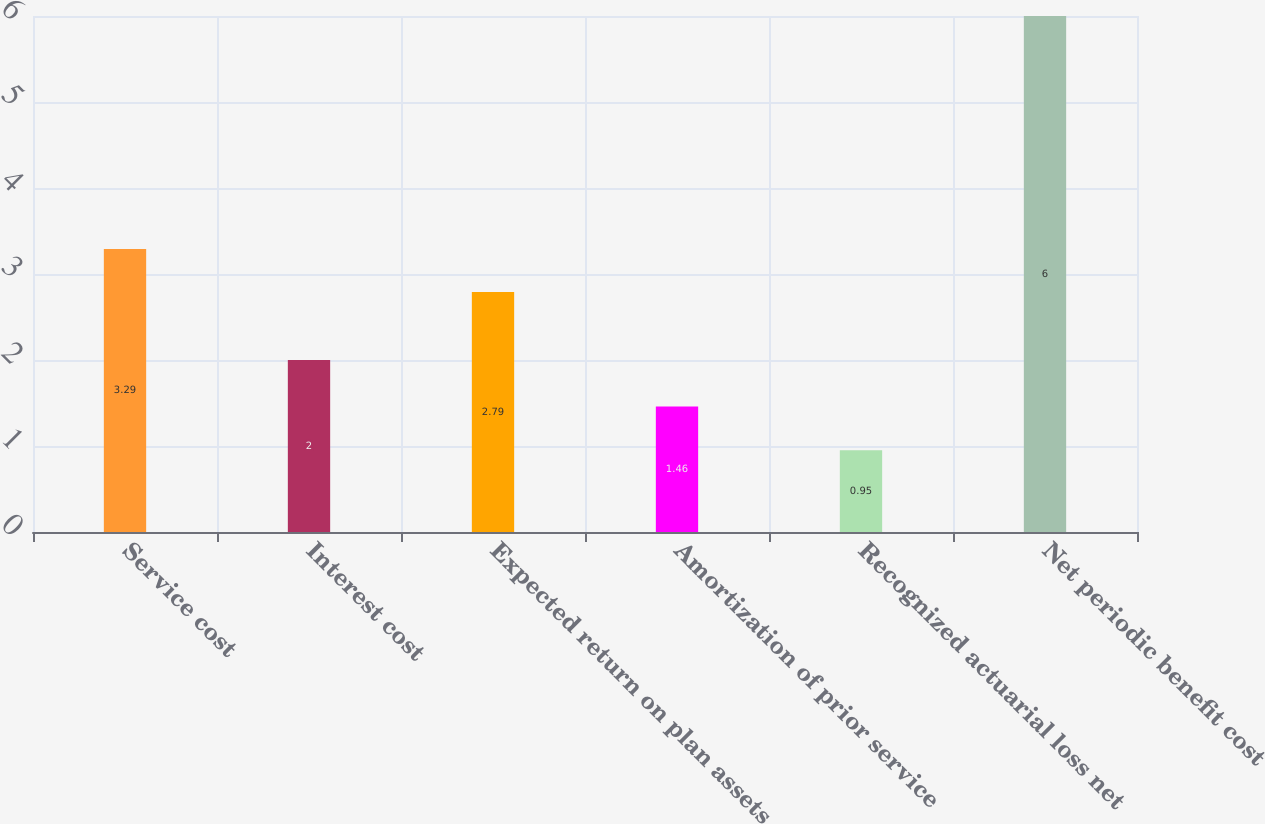Convert chart to OTSL. <chart><loc_0><loc_0><loc_500><loc_500><bar_chart><fcel>Service cost<fcel>Interest cost<fcel>Expected return on plan assets<fcel>Amortization of prior service<fcel>Recognized actuarial loss net<fcel>Net periodic benefit cost<nl><fcel>3.29<fcel>2<fcel>2.79<fcel>1.46<fcel>0.95<fcel>6<nl></chart> 